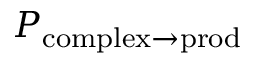Convert formula to latex. <formula><loc_0><loc_0><loc_500><loc_500>P _ { c o m p l e x \to p r o d }</formula> 